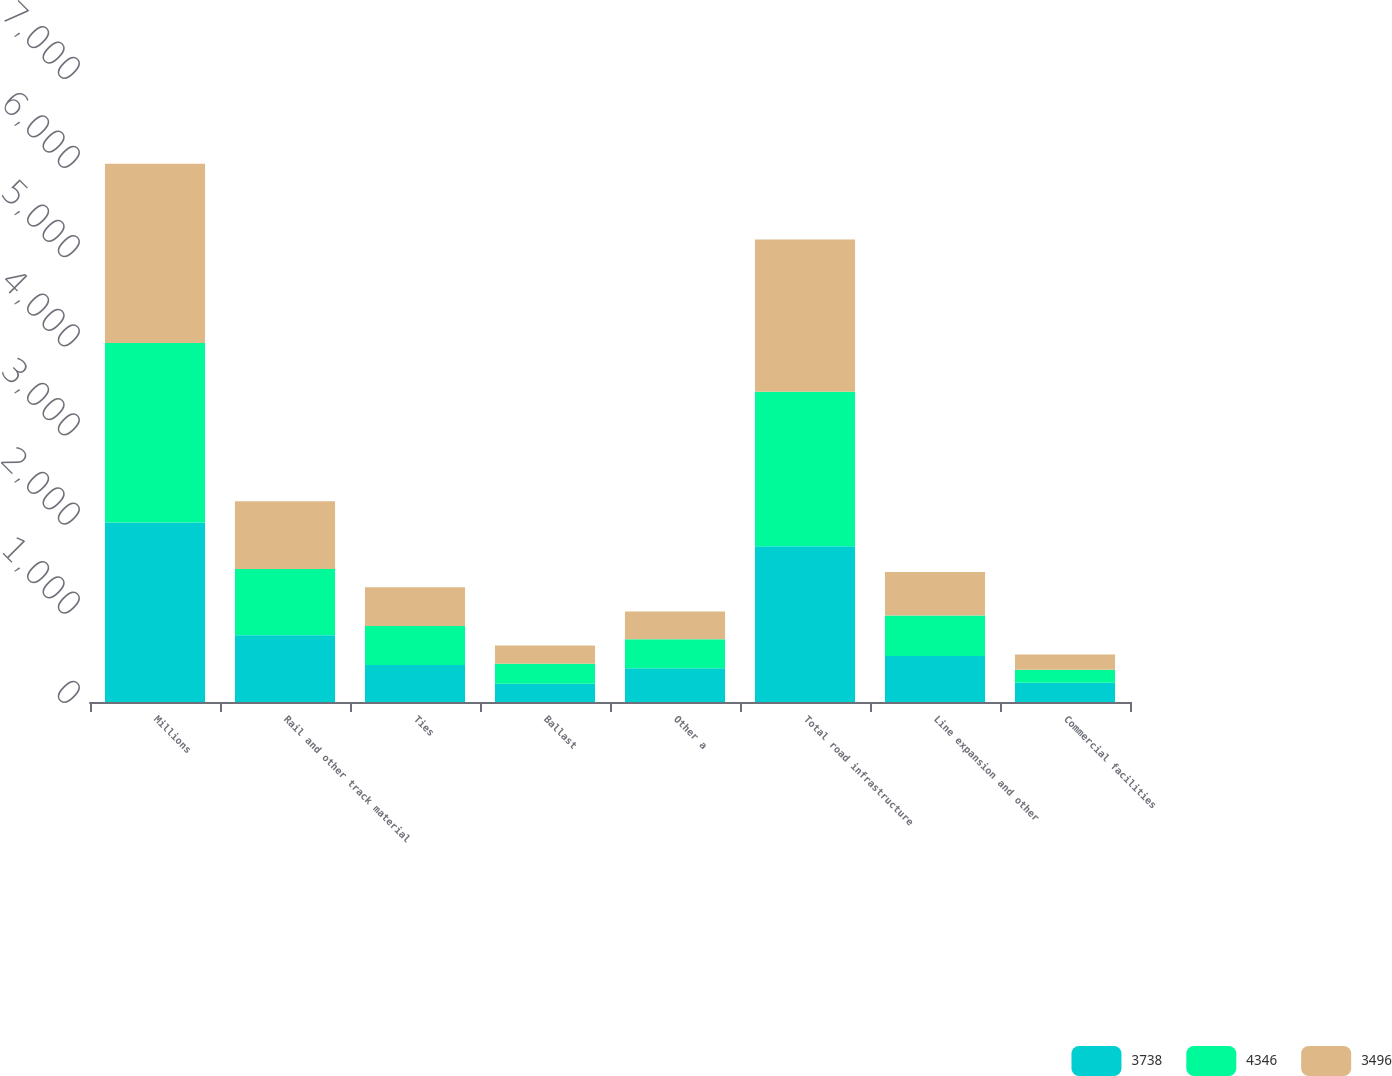Convert chart. <chart><loc_0><loc_0><loc_500><loc_500><stacked_bar_chart><ecel><fcel>Millions<fcel>Rail and other track material<fcel>Ties<fcel>Ballast<fcel>Other a<fcel>Total road infrastructure<fcel>Line expansion and other<fcel>Commercial facilities<nl><fcel>3738<fcel>2014<fcel>749<fcel>415<fcel>204<fcel>378<fcel>1746<fcel>515<fcel>217<nl><fcel>4346<fcel>2013<fcel>743<fcel>438<fcel>226<fcel>326<fcel>1733<fcel>455<fcel>146<nl><fcel>3496<fcel>2012<fcel>759<fcel>434<fcel>203<fcel>312<fcel>1708<fcel>489<fcel>169<nl></chart> 